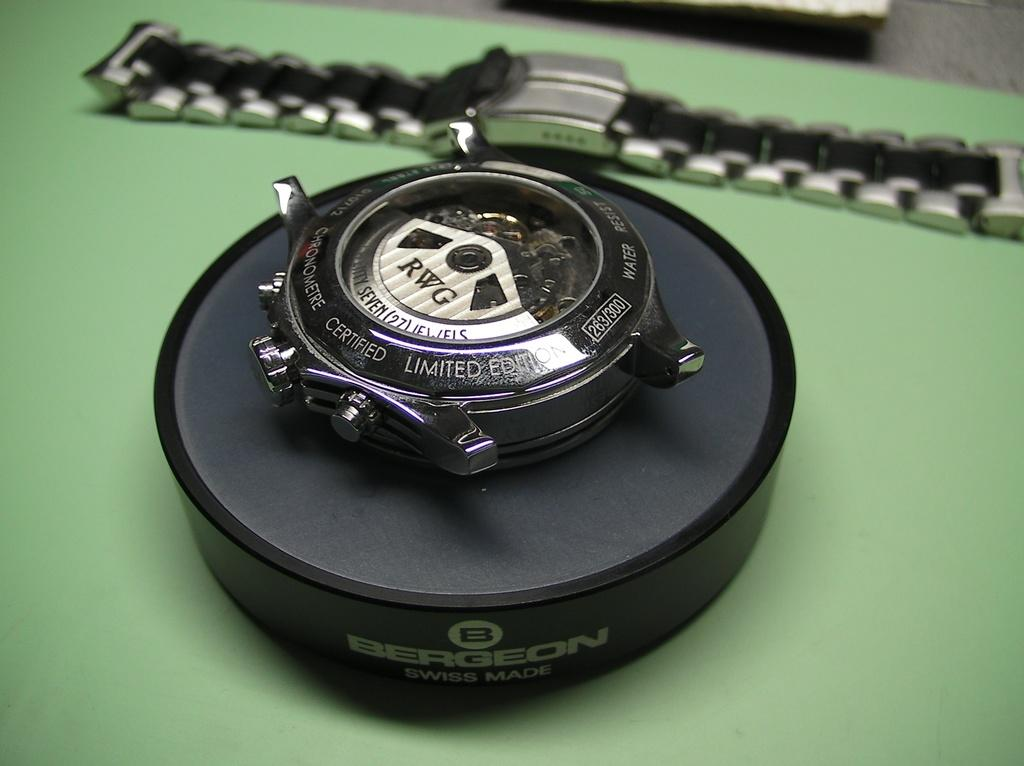<image>
Provide a brief description of the given image. A watch face sitting on a stand that has the name Bergeon on it and advertising that it is Swiss Made. 